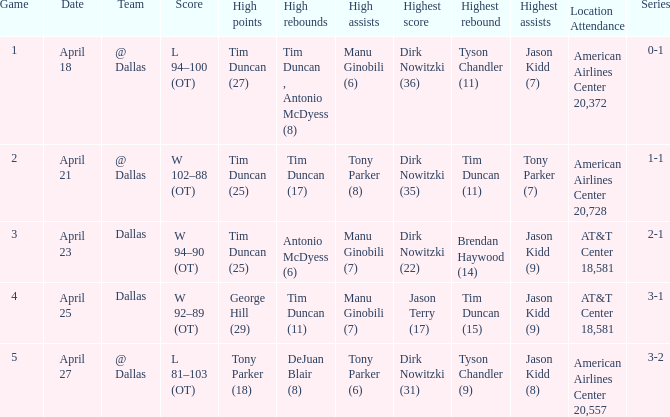When 1-1 is the series who is the team? @ Dallas. 